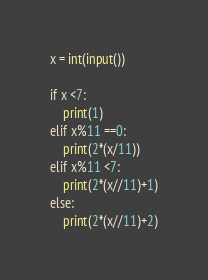Convert code to text. <code><loc_0><loc_0><loc_500><loc_500><_Python_>x = int(input())

if x <7:
    print(1)
elif x%11 ==0:
    print(2*(x/11))
elif x%11 <7:
    print(2*(x//11)+1)
else:
    print(2*(x//11)+2)</code> 